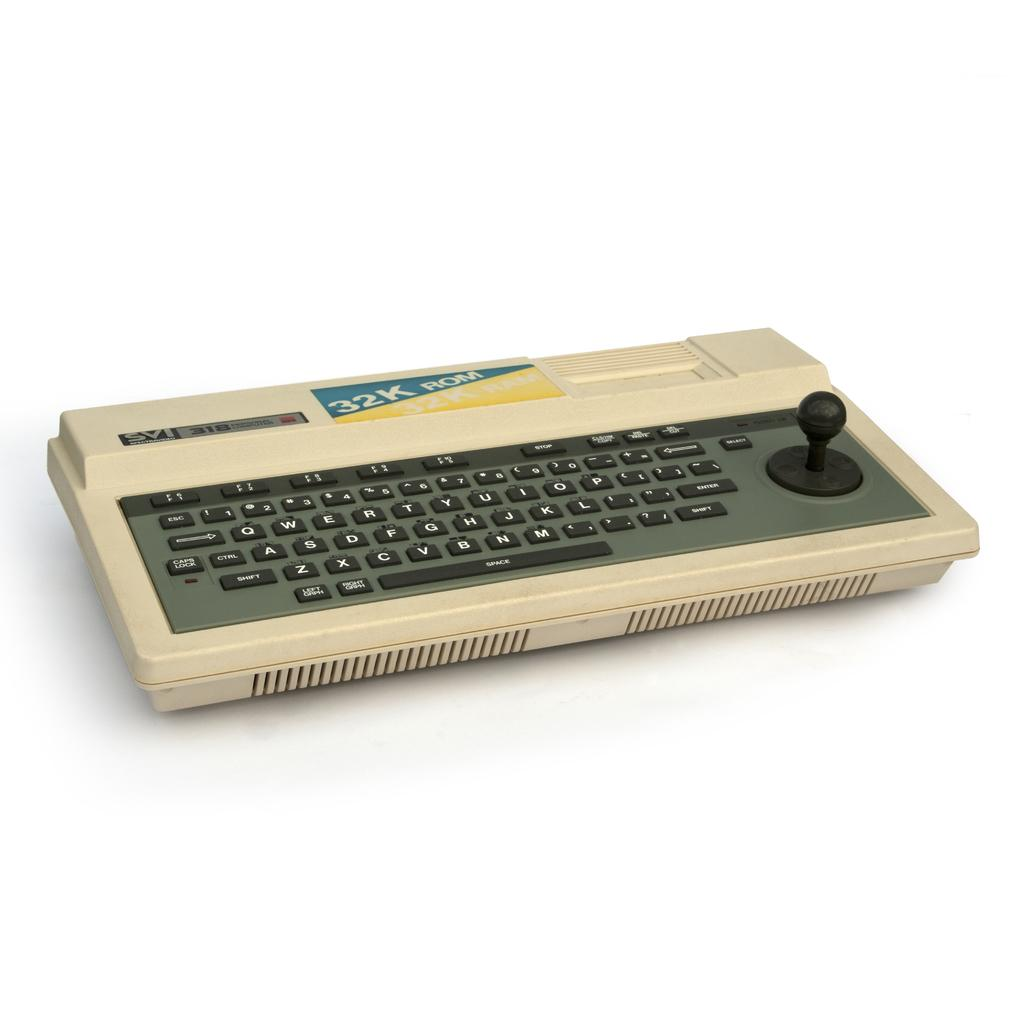<image>
Provide a brief description of the given image. A keyboard has a label with 32K printed on it on the top. 